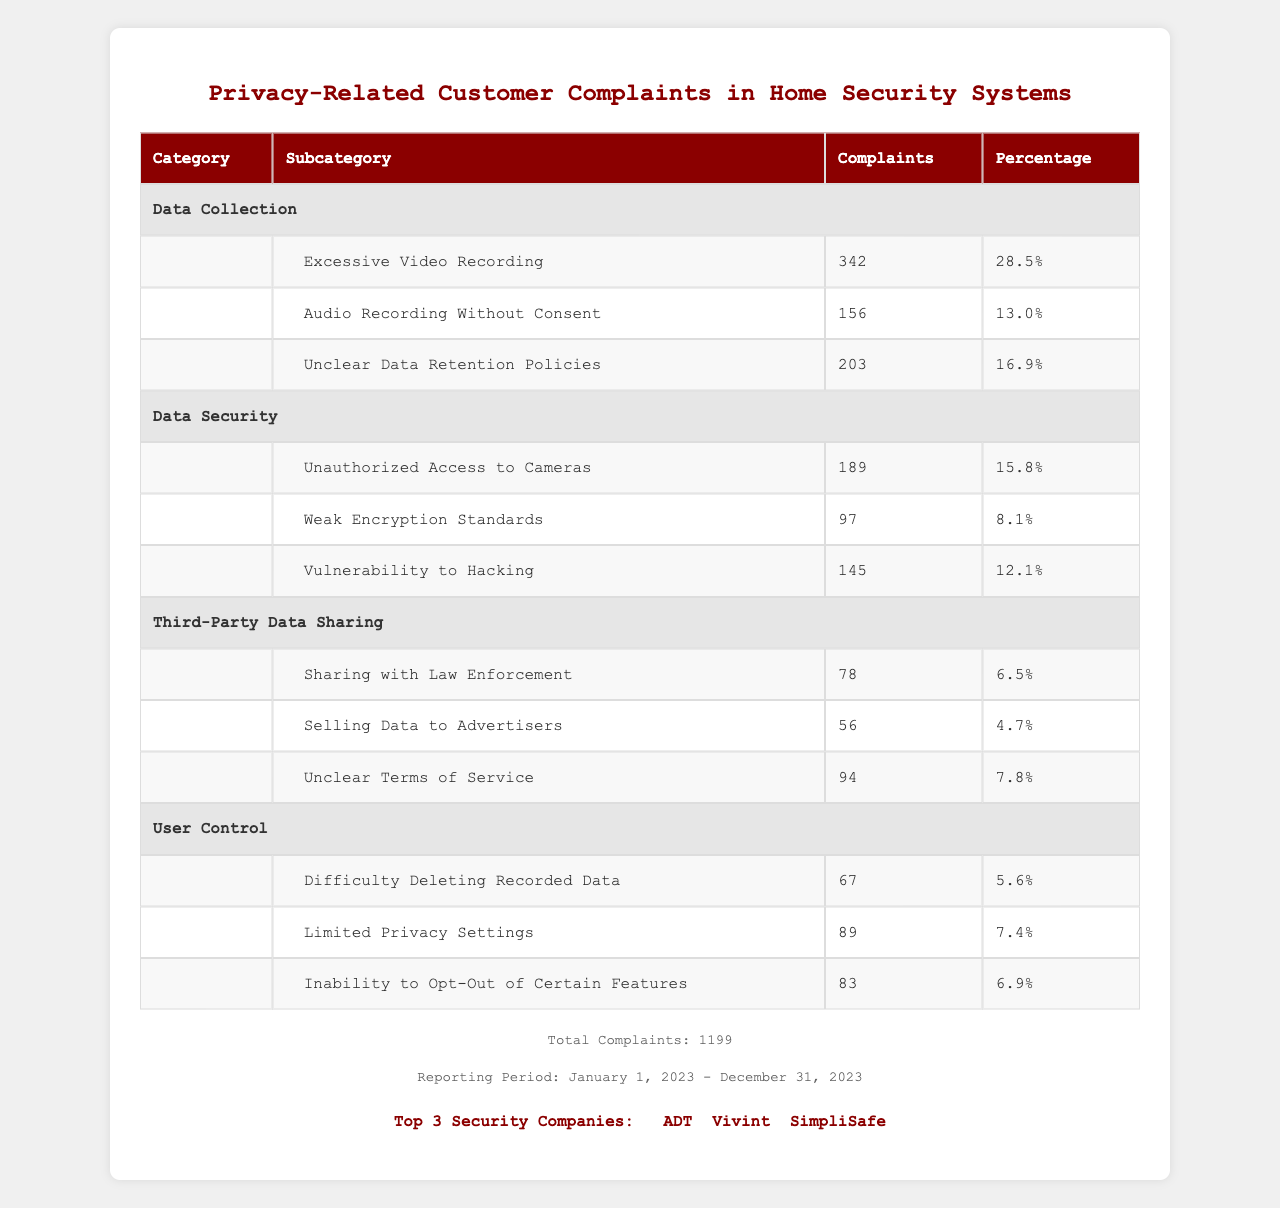What is the category with the most complaints? The table shows various categories of customer complaints, and the category "Data Collection" has the highest number of complaints with 701 total complaints (342 + 156 + 203).
Answer: Data Collection How many complaints were related to "Unauthorized Access to Cameras"? The subcategory "Unauthorized Access to Cameras" under the "Data Security" category has 189 complaints listed in the table.
Answer: 189 What percentage of complaints are related to "Audio Recording Without Consent"? The table indicates that "Audio Recording Without Consent" has 156 complaints, which is 13.0% of the total 1199 complaints (calculated as (156/1199) * 100). Hence, the percentage is confirmed as correct.
Answer: 13.0% Which subcategory has the least complaints? The table indicates that the subcategory with the least number of complaints is "Selling Data to Advertisers," with only 56 complaints, making it the lowest in the entire table.
Answer: Selling Data to Advertisers What is the total number of complaints in the "User Control" category? The table shows that "User Control" has three subcategories with complaints: 67 for "Difficulty Deleting Recorded Data," 89 for "Limited Privacy Settings," and 83 for "Inability to Opt-Out of Certain Features." Adding these gives a total of 239 complaints (67 + 89 + 83).
Answer: 239 Are there more complaints about data security or data collection? Data Security has a total of 431 complaints (189 + 97 + 145), while Data Collection has 701 complaints (342 + 156 + 203). Therefore, Data Collection has more complaints than Data Security.
Answer: Yes What is the total percentage of complaints attributed to "Data Security"? The total complaints for Data Security are 431 (as calculated previously). To find the percentage, we divide 431 by 1199 and multiply by 100: (431/1199) * 100 which equals approximately 35.9%.
Answer: 35.9% How many complaints are related to "Unclear Data Retention Policies” compared to "Vulnerability to Hacking"? "Unclear Data Retention Policies" has 203 complaints, while "Vulnerability to Hacking" has 145 complaints. This shows that complaints regarding Unclear Data Retention Policies are higher by 58 (203 - 145).
Answer: 58 more complaints for Unclear Data Retention Policies What fraction of the total complaints deals with third-party data sharing? The total complaints in the Third-Party Data Sharing category add up to 228 (78 + 56 + 94). To find the fraction, divide 228 by 1199 which equals approximately 0.190.
Answer: Approximately 0.190 Which company appears most frequently in customer complaints related to privacy? Based on the provided information, the top three security companies listed are ADT, Vivint, and SimpliSafe. However, the table does not provide information on complaints attributed to these companies individually. Therefore, I cannot determine which company appears most frequently.
Answer: Not determinable from the table 